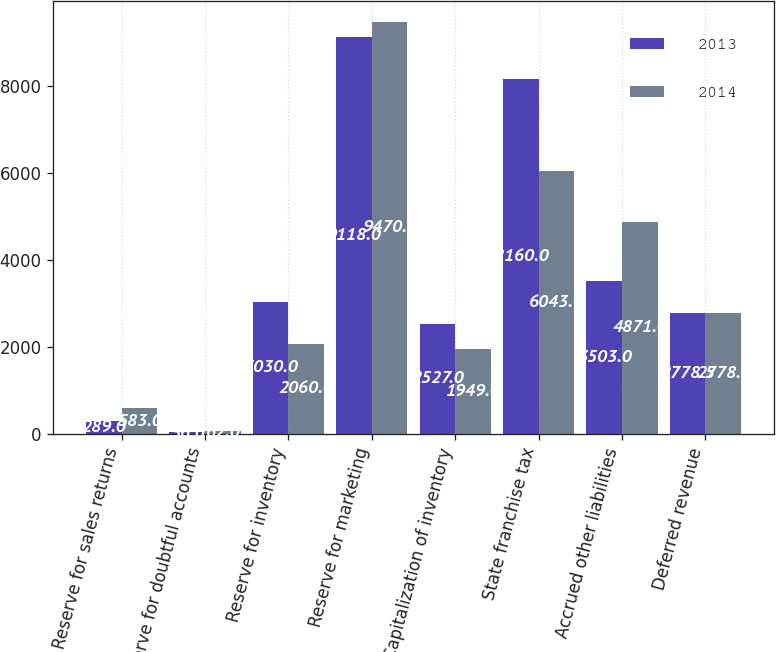Convert chart to OTSL. <chart><loc_0><loc_0><loc_500><loc_500><stacked_bar_chart><ecel><fcel>Reserve for sales returns<fcel>Reserve for doubtful accounts<fcel>Reserve for inventory<fcel>Reserve for marketing<fcel>Capitalization of inventory<fcel>State franchise tax<fcel>Accrued other liabilities<fcel>Deferred revenue<nl><fcel>2013<fcel>289<fcel>36<fcel>3030<fcel>9118<fcel>2527<fcel>8160<fcel>3503<fcel>2778.5<nl><fcel>2014<fcel>583<fcel>62<fcel>2060<fcel>9470<fcel>1949<fcel>6043<fcel>4871<fcel>2778.5<nl></chart> 